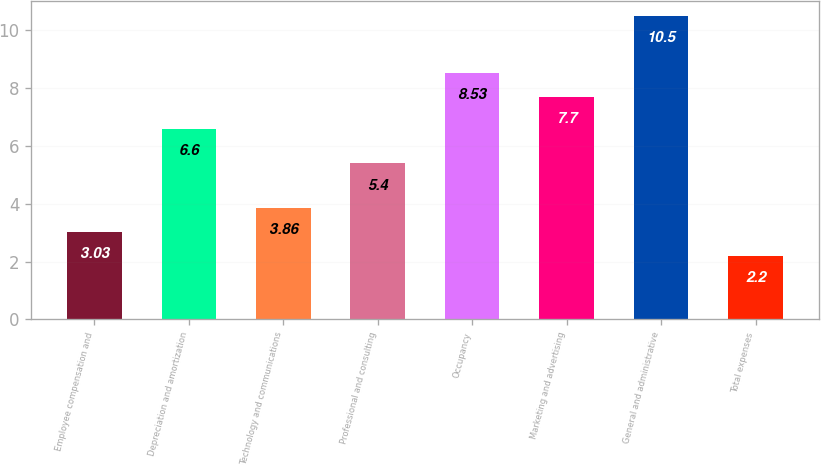<chart> <loc_0><loc_0><loc_500><loc_500><bar_chart><fcel>Employee compensation and<fcel>Depreciation and amortization<fcel>Technology and communications<fcel>Professional and consulting<fcel>Occupancy<fcel>Marketing and advertising<fcel>General and administrative<fcel>Total expenses<nl><fcel>3.03<fcel>6.6<fcel>3.86<fcel>5.4<fcel>8.53<fcel>7.7<fcel>10.5<fcel>2.2<nl></chart> 